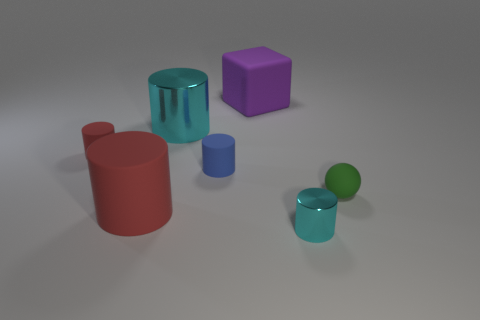Subtract all red cylinders. How many cylinders are left? 3 Subtract all blue rubber cylinders. How many cylinders are left? 4 Subtract all yellow cylinders. Subtract all cyan cubes. How many cylinders are left? 5 Add 2 tiny blue objects. How many objects exist? 9 Subtract all cylinders. How many objects are left? 2 Subtract all tiny matte things. Subtract all blue matte objects. How many objects are left? 3 Add 3 large purple objects. How many large purple objects are left? 4 Add 6 tiny brown matte objects. How many tiny brown matte objects exist? 6 Subtract 0 gray cubes. How many objects are left? 7 